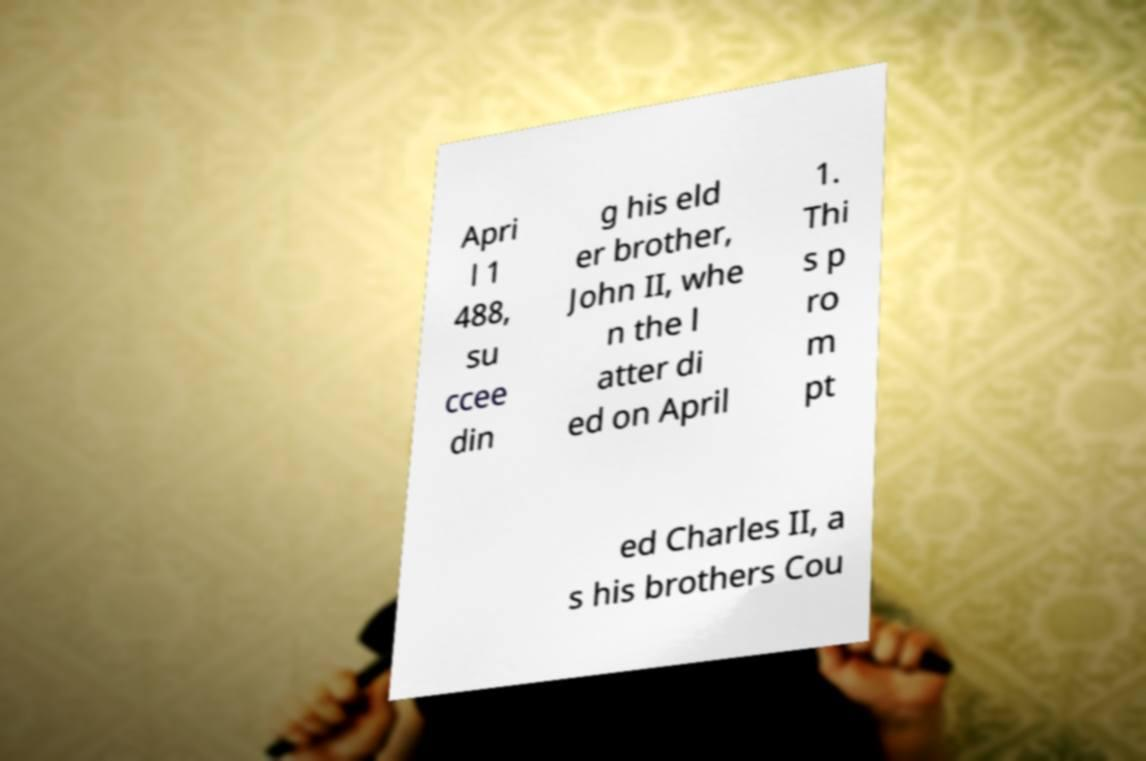There's text embedded in this image that I need extracted. Can you transcribe it verbatim? Apri l 1 488, su ccee din g his eld er brother, John II, whe n the l atter di ed on April 1. Thi s p ro m pt ed Charles II, a s his brothers Cou 